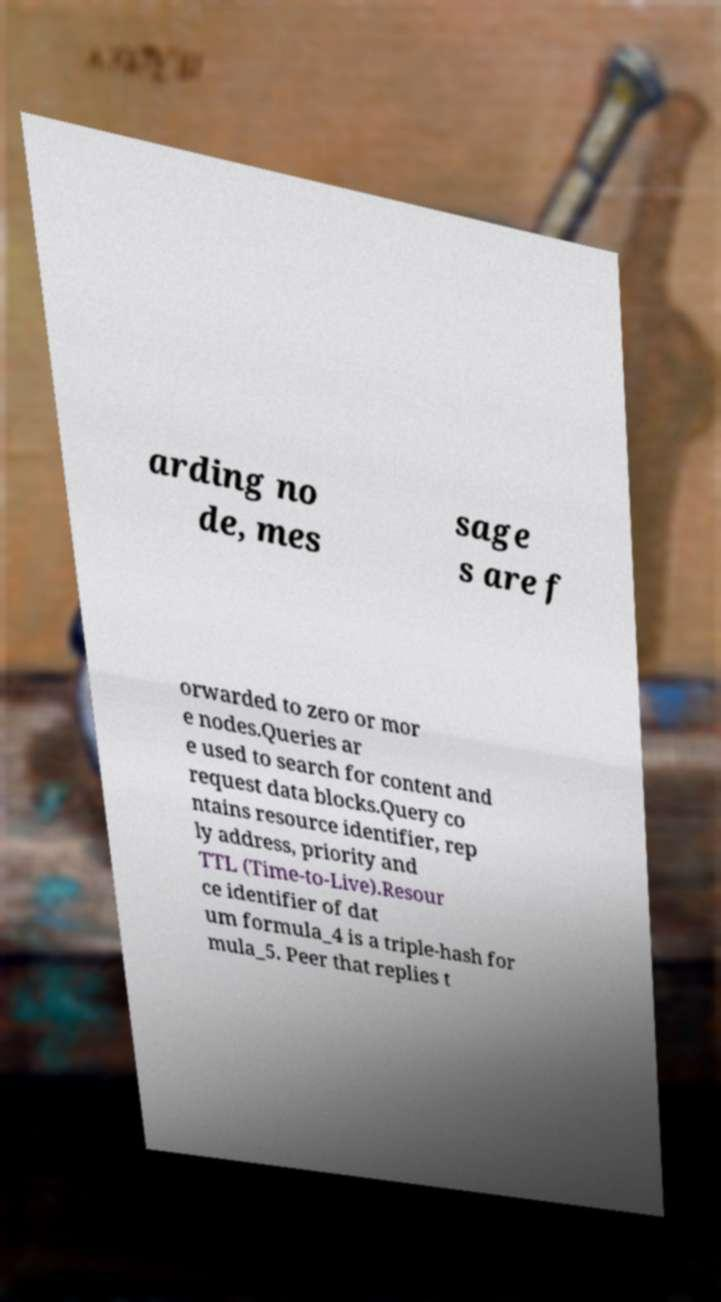Please identify and transcribe the text found in this image. arding no de, mes sage s are f orwarded to zero or mor e nodes.Queries ar e used to search for content and request data blocks.Query co ntains resource identifier, rep ly address, priority and TTL (Time-to-Live).Resour ce identifier of dat um formula_4 is a triple-hash for mula_5. Peer that replies t 